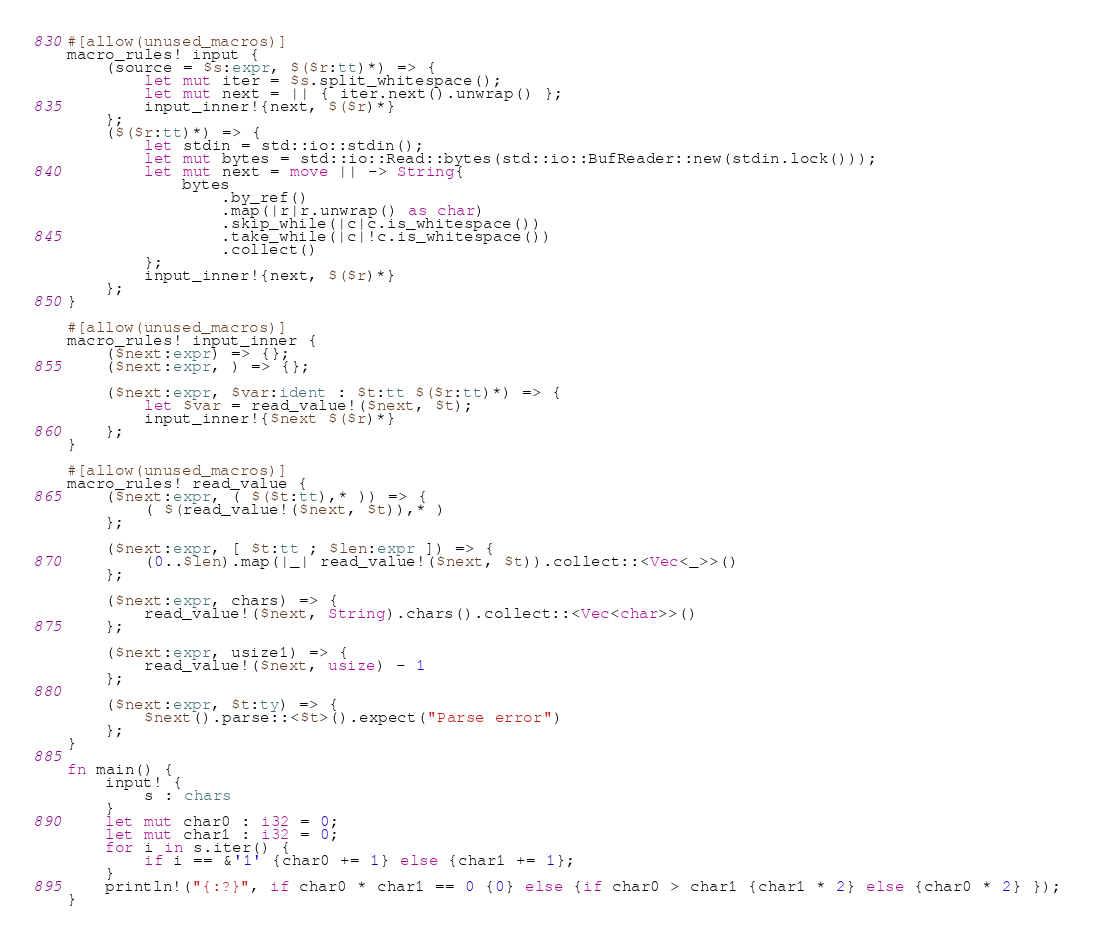<code> <loc_0><loc_0><loc_500><loc_500><_Rust_>
#[allow(unused_macros)]
macro_rules! input {
    (source = $s:expr, $($r:tt)*) => {
        let mut iter = $s.split_whitespace();
        let mut next = || { iter.next().unwrap() };
        input_inner!{next, $($r)*}
    };
    ($($r:tt)*) => {
        let stdin = std::io::stdin();
        let mut bytes = std::io::Read::bytes(std::io::BufReader::new(stdin.lock()));
        let mut next = move || -> String{
            bytes
                .by_ref()
                .map(|r|r.unwrap() as char)
                .skip_while(|c|c.is_whitespace())
                .take_while(|c|!c.is_whitespace())
                .collect()
        };
        input_inner!{next, $($r)*}
    };
}

#[allow(unused_macros)]
macro_rules! input_inner {
    ($next:expr) => {};
    ($next:expr, ) => {};

    ($next:expr, $var:ident : $t:tt $($r:tt)*) => {
        let $var = read_value!($next, $t);
        input_inner!{$next $($r)*}
    };
}

#[allow(unused_macros)]
macro_rules! read_value {
    ($next:expr, ( $($t:tt),* )) => {
        ( $(read_value!($next, $t)),* )
    };

    ($next:expr, [ $t:tt ; $len:expr ]) => {
        (0..$len).map(|_| read_value!($next, $t)).collect::<Vec<_>>()
    };

    ($next:expr, chars) => {
        read_value!($next, String).chars().collect::<Vec<char>>()
    };

    ($next:expr, usize1) => {
        read_value!($next, usize) - 1
    };

    ($next:expr, $t:ty) => {
        $next().parse::<$t>().expect("Parse error")
    };
}

fn main() {
    input! {
        s : chars
    }
    let mut char0 : i32 = 0;
    let mut char1 : i32 = 0;
    for i in s.iter() {
        if i == &'1' {char0 += 1} else {char1 += 1};
    }
    println!("{:?}", if char0 * char1 == 0 {0} else {if char0 > char1 {char1 * 2} else {char0 * 2} });
}

</code> 